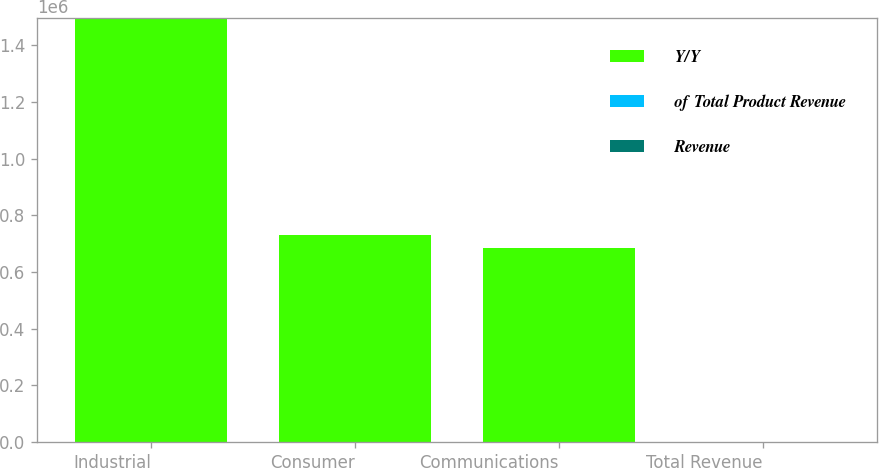<chart> <loc_0><loc_0><loc_500><loc_500><stacked_bar_chart><ecel><fcel>Industrial<fcel>Consumer<fcel>Communications<fcel>Total Revenue<nl><fcel>Y/Y<fcel>1.4962e+06<fcel>729965<fcel>682805<fcel>44<nl><fcel>of Total Product Revenue<fcel>44<fcel>21<fcel>20<fcel>100<nl><fcel>Revenue<fcel>11<fcel>123<fcel>2<fcel>20<nl></chart> 